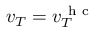<formula> <loc_0><loc_0><loc_500><loc_500>v _ { T } = v _ { T } ^ { h c }</formula> 